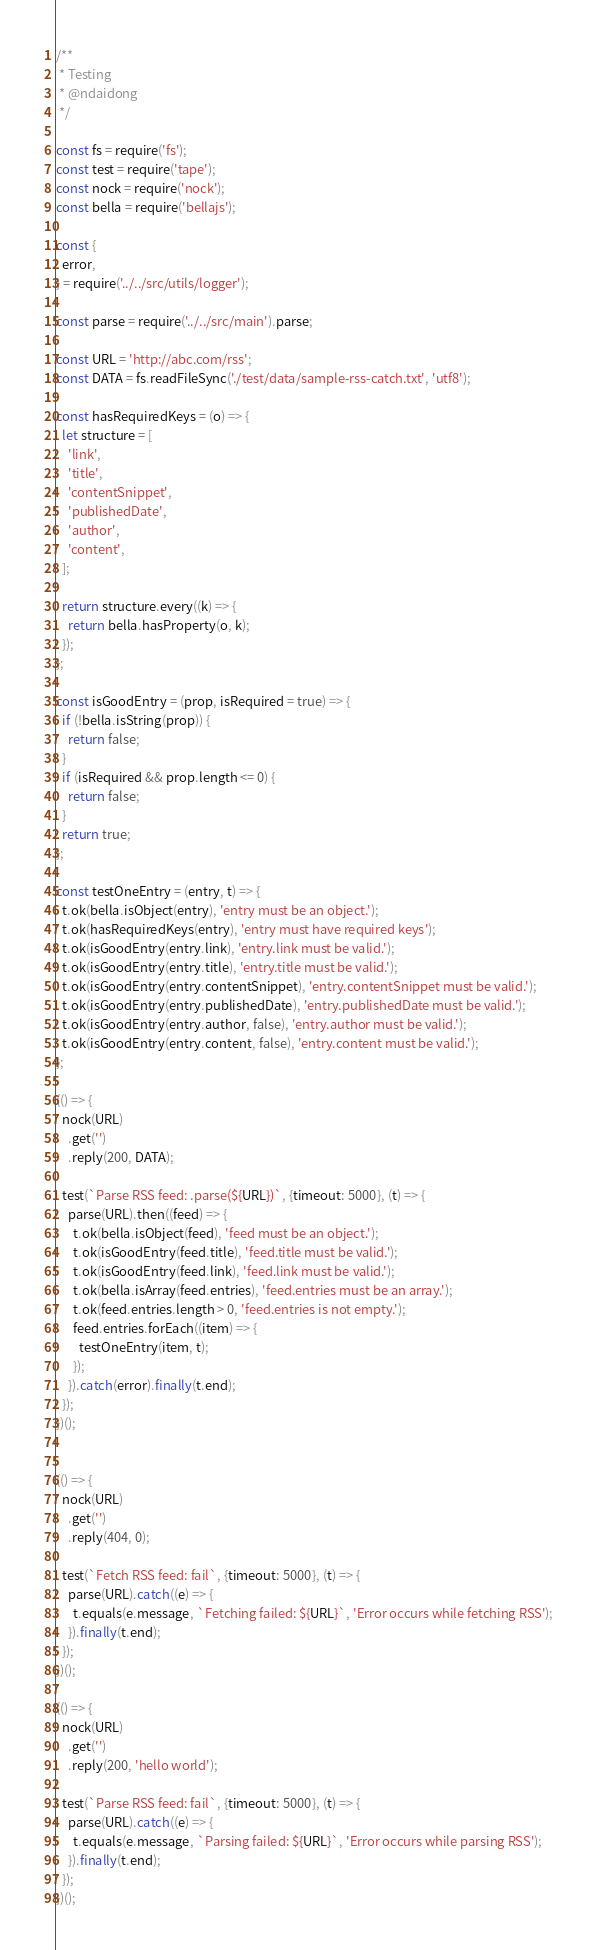Convert code to text. <code><loc_0><loc_0><loc_500><loc_500><_JavaScript_>/**
 * Testing
 * @ndaidong
 */

const fs = require('fs');
const test = require('tape');
const nock = require('nock');
const bella = require('bellajs');

const {
  error,
} = require('../../src/utils/logger');

const parse = require('../../src/main').parse;

const URL = 'http://abc.com/rss';
const DATA = fs.readFileSync('./test/data/sample-rss-catch.txt', 'utf8');

const hasRequiredKeys = (o) => {
  let structure = [
    'link',
    'title',
    'contentSnippet',
    'publishedDate',
    'author',
    'content',
  ];

  return structure.every((k) => {
    return bella.hasProperty(o, k);
  });
};

const isGoodEntry = (prop, isRequired = true) => {
  if (!bella.isString(prop)) {
    return false;
  }
  if (isRequired && prop.length <= 0) {
    return false;
  }
  return true;
};

const testOneEntry = (entry, t) => {
  t.ok(bella.isObject(entry), 'entry must be an object.');
  t.ok(hasRequiredKeys(entry), 'entry must have required keys');
  t.ok(isGoodEntry(entry.link), 'entry.link must be valid.');
  t.ok(isGoodEntry(entry.title), 'entry.title must be valid.');
  t.ok(isGoodEntry(entry.contentSnippet), 'entry.contentSnippet must be valid.');
  t.ok(isGoodEntry(entry.publishedDate), 'entry.publishedDate must be valid.');
  t.ok(isGoodEntry(entry.author, false), 'entry.author must be valid.');
  t.ok(isGoodEntry(entry.content, false), 'entry.content must be valid.');
};

(() => {
  nock(URL)
    .get('')
    .reply(200, DATA);

  test(`Parse RSS feed: .parse(${URL})`, {timeout: 5000}, (t) => {
    parse(URL).then((feed) => {
      t.ok(bella.isObject(feed), 'feed must be an object.');
      t.ok(isGoodEntry(feed.title), 'feed.title must be valid.');
      t.ok(isGoodEntry(feed.link), 'feed.link must be valid.');
      t.ok(bella.isArray(feed.entries), 'feed.entries must be an array.');
      t.ok(feed.entries.length > 0, 'feed.entries is not empty.');
      feed.entries.forEach((item) => {
        testOneEntry(item, t);
      });
    }).catch(error).finally(t.end);
  });
})();


(() => {
  nock(URL)
    .get('')
    .reply(404, 0);

  test(`Fetch RSS feed: fail`, {timeout: 5000}, (t) => {
    parse(URL).catch((e) => {
      t.equals(e.message, `Fetching failed: ${URL}`, 'Error occurs while fetching RSS');
    }).finally(t.end);
  });
})();

(() => {
  nock(URL)
    .get('')
    .reply(200, 'hello world');

  test(`Parse RSS feed: fail`, {timeout: 5000}, (t) => {
    parse(URL).catch((e) => {
      t.equals(e.message, `Parsing failed: ${URL}`, 'Error occurs while parsing RSS');
    }).finally(t.end);
  });
})();
</code> 